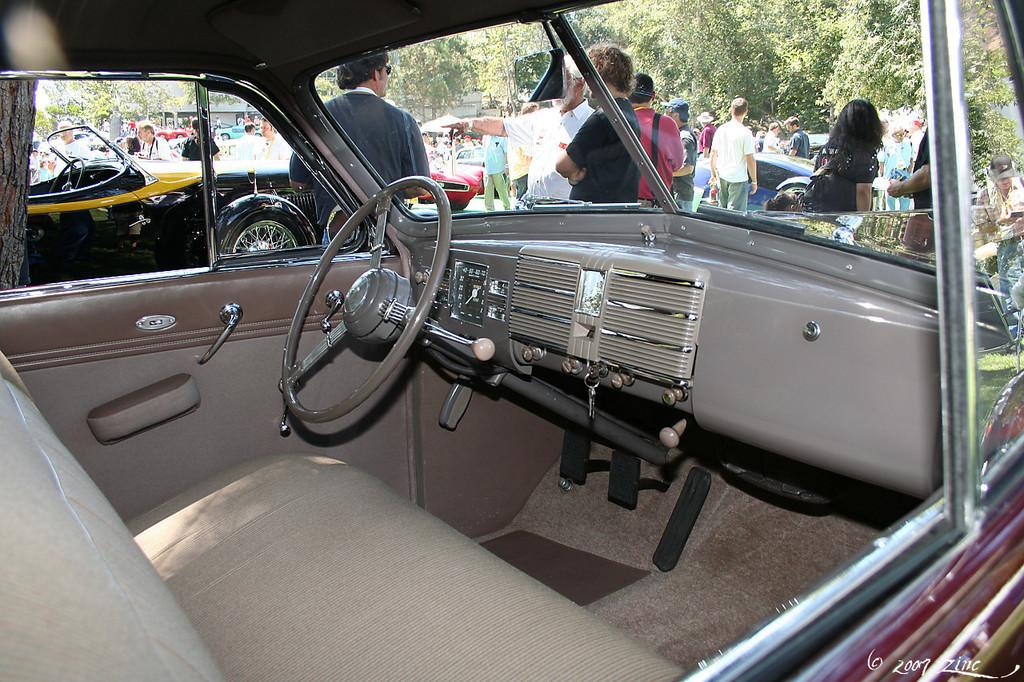What can be seen on the road in the image in the image? There are vehicles and a crowd on the road in the image. What is visible at the top of the image? Trees and houses are visible at the top of the image. When was the image taken? The image was taken during the day. What type of insurance is being sold by the crowd in the image? There is no indication in the image that insurance is being sold or discussed. How many units are visible in the image? The concept of "units" is not mentioned or relevant to the image, so it cannot be determined from the image. 